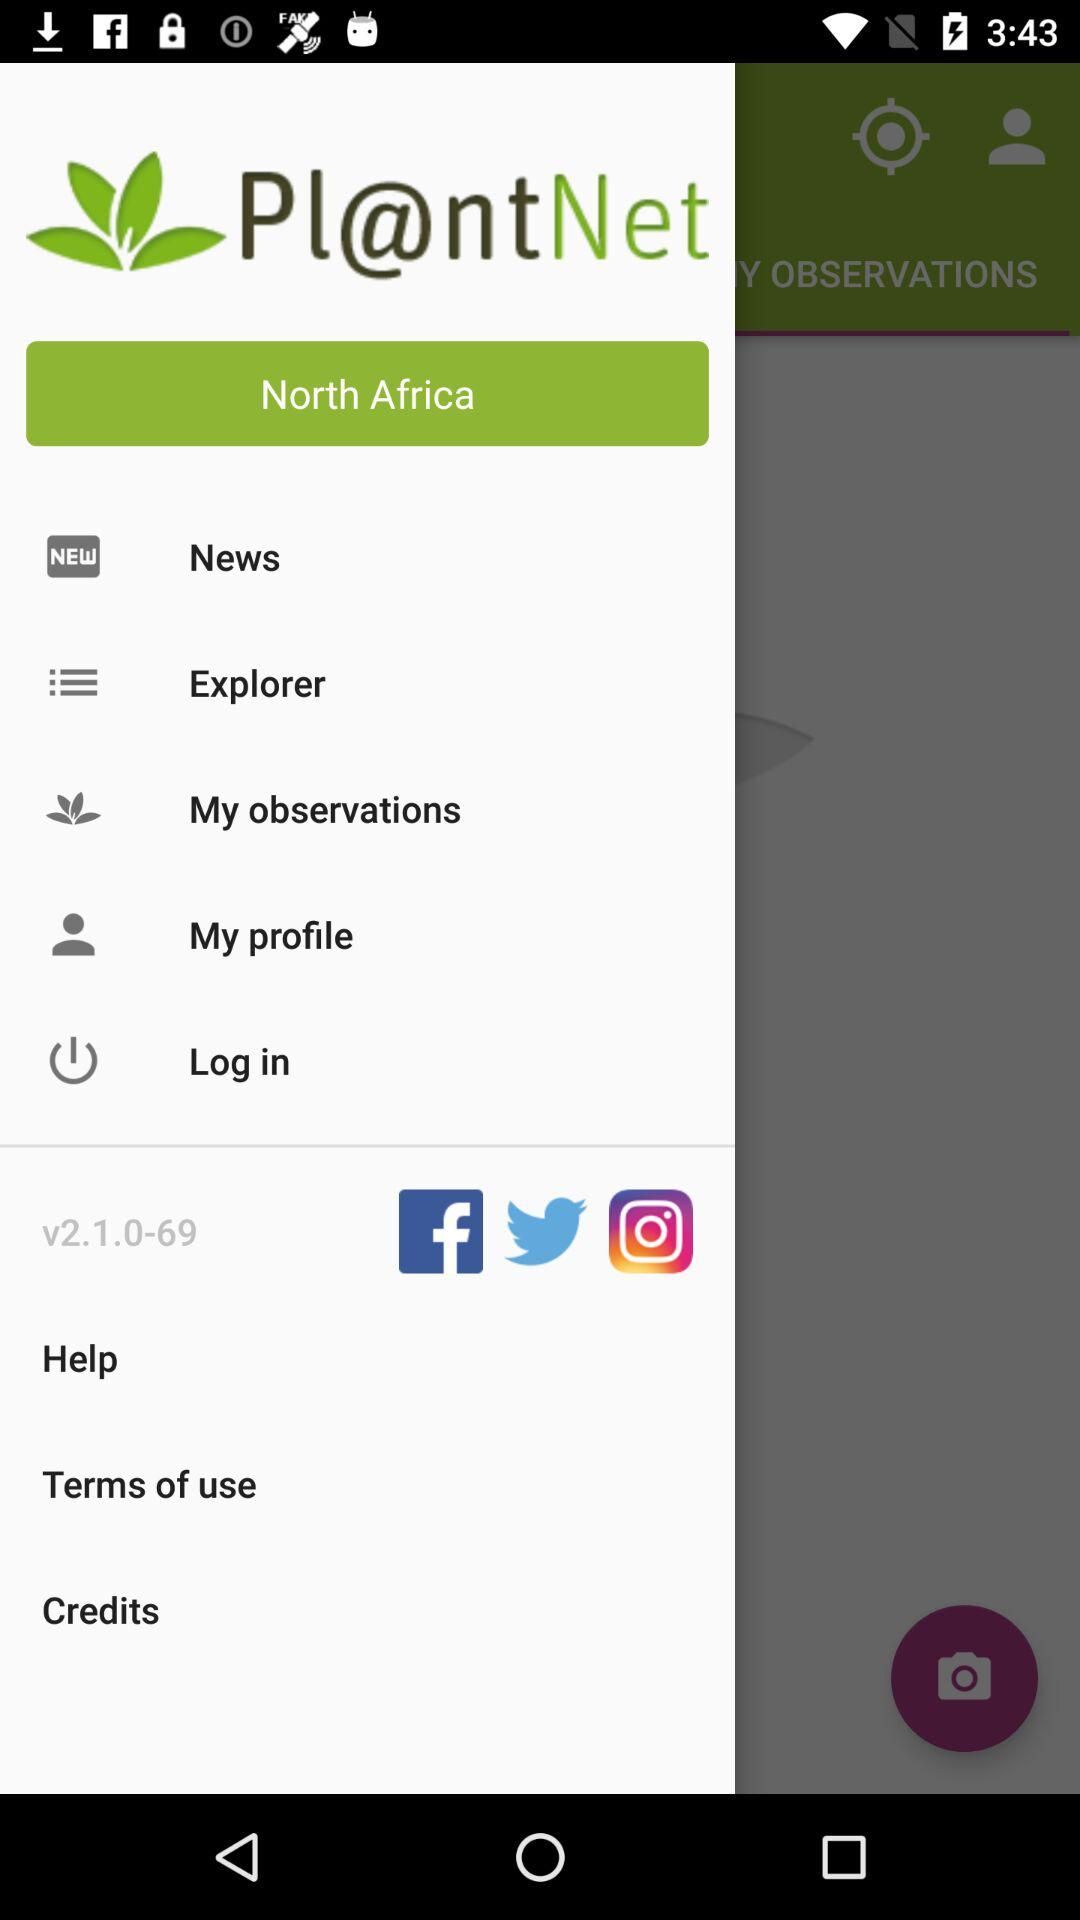What is the location? The location is North Africa. 